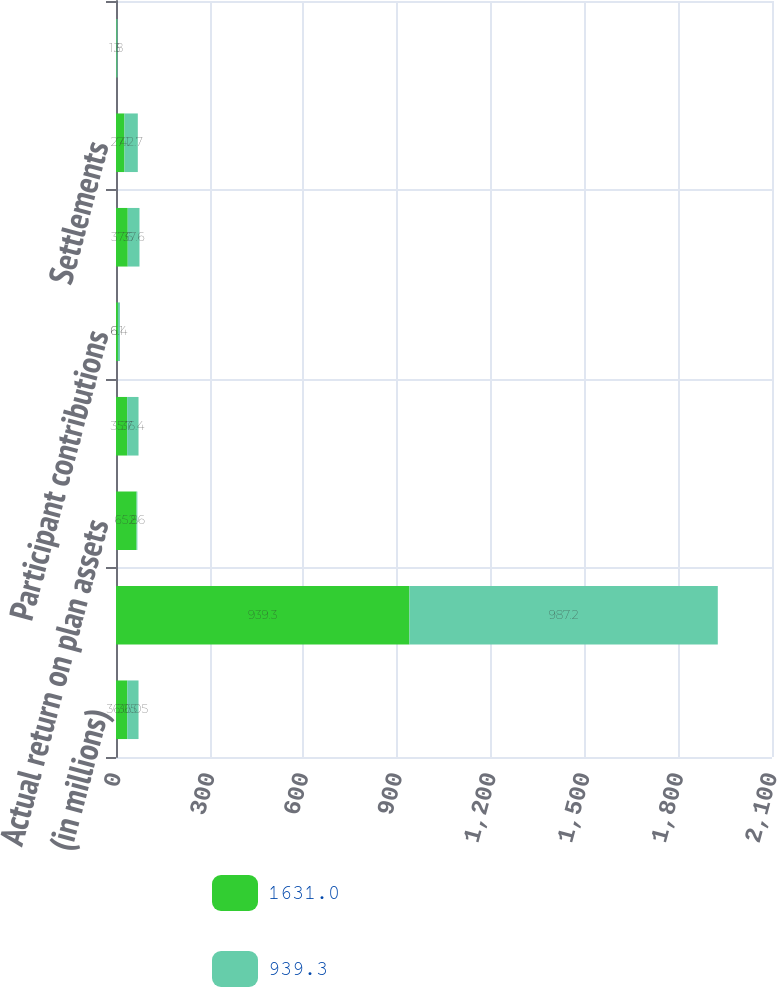Convert chart. <chart><loc_0><loc_0><loc_500><loc_500><stacked_bar_chart><ecel><fcel>(in millions)<fcel>Fair value of plan assets at<fcel>Actual return on plan assets<fcel>Employer contributions<fcel>Participant contributions<fcel>Benefits paid<fcel>Settlements<fcel>Administrative expenses<nl><fcel>1631<fcel>36.05<fcel>939.3<fcel>65.8<fcel>35.7<fcel>6.1<fcel>37.6<fcel>27.1<fcel>1.8<nl><fcel>939.3<fcel>36.05<fcel>987.2<fcel>2.6<fcel>36.4<fcel>6.4<fcel>37.6<fcel>42.7<fcel>3<nl></chart> 